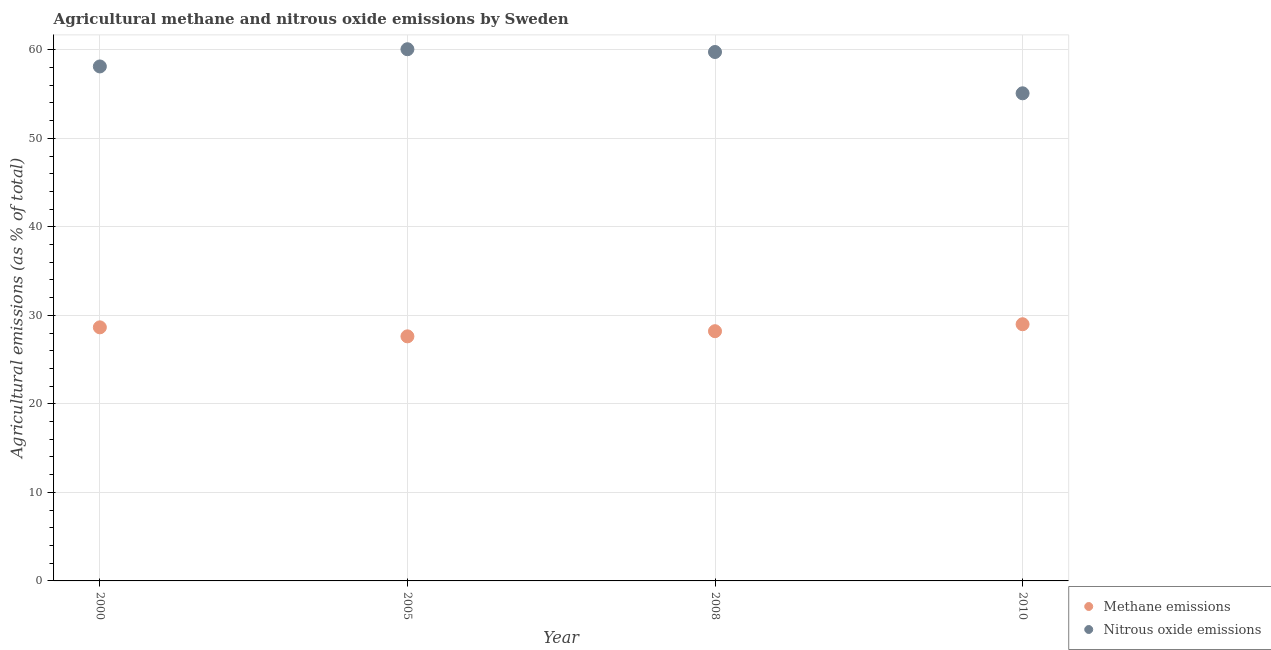What is the amount of methane emissions in 2008?
Keep it short and to the point. 28.21. Across all years, what is the maximum amount of methane emissions?
Give a very brief answer. 29. Across all years, what is the minimum amount of methane emissions?
Keep it short and to the point. 27.63. In which year was the amount of methane emissions maximum?
Keep it short and to the point. 2010. In which year was the amount of methane emissions minimum?
Your answer should be very brief. 2005. What is the total amount of methane emissions in the graph?
Provide a short and direct response. 113.48. What is the difference between the amount of nitrous oxide emissions in 2005 and that in 2008?
Offer a terse response. 0.31. What is the difference between the amount of nitrous oxide emissions in 2008 and the amount of methane emissions in 2005?
Your response must be concise. 32.12. What is the average amount of methane emissions per year?
Provide a short and direct response. 28.37. In the year 2008, what is the difference between the amount of nitrous oxide emissions and amount of methane emissions?
Your response must be concise. 31.54. What is the ratio of the amount of methane emissions in 2005 to that in 2010?
Ensure brevity in your answer.  0.95. Is the difference between the amount of nitrous oxide emissions in 2000 and 2010 greater than the difference between the amount of methane emissions in 2000 and 2010?
Ensure brevity in your answer.  Yes. What is the difference between the highest and the second highest amount of nitrous oxide emissions?
Your answer should be compact. 0.31. What is the difference between the highest and the lowest amount of methane emissions?
Your response must be concise. 1.37. Does the amount of methane emissions monotonically increase over the years?
Your answer should be very brief. No. Is the amount of methane emissions strictly less than the amount of nitrous oxide emissions over the years?
Your response must be concise. Yes. How many dotlines are there?
Ensure brevity in your answer.  2. What is the difference between two consecutive major ticks on the Y-axis?
Offer a terse response. 10. Are the values on the major ticks of Y-axis written in scientific E-notation?
Your answer should be very brief. No. Does the graph contain grids?
Provide a short and direct response. Yes. Where does the legend appear in the graph?
Keep it short and to the point. Bottom right. How are the legend labels stacked?
Your answer should be compact. Vertical. What is the title of the graph?
Provide a short and direct response. Agricultural methane and nitrous oxide emissions by Sweden. What is the label or title of the Y-axis?
Your answer should be very brief. Agricultural emissions (as % of total). What is the Agricultural emissions (as % of total) of Methane emissions in 2000?
Your answer should be very brief. 28.65. What is the Agricultural emissions (as % of total) in Nitrous oxide emissions in 2000?
Keep it short and to the point. 58.12. What is the Agricultural emissions (as % of total) in Methane emissions in 2005?
Provide a succinct answer. 27.63. What is the Agricultural emissions (as % of total) of Nitrous oxide emissions in 2005?
Your answer should be very brief. 60.06. What is the Agricultural emissions (as % of total) of Methane emissions in 2008?
Ensure brevity in your answer.  28.21. What is the Agricultural emissions (as % of total) of Nitrous oxide emissions in 2008?
Your response must be concise. 59.75. What is the Agricultural emissions (as % of total) in Methane emissions in 2010?
Offer a very short reply. 29. What is the Agricultural emissions (as % of total) in Nitrous oxide emissions in 2010?
Offer a terse response. 55.09. Across all years, what is the maximum Agricultural emissions (as % of total) in Methane emissions?
Offer a very short reply. 29. Across all years, what is the maximum Agricultural emissions (as % of total) in Nitrous oxide emissions?
Provide a succinct answer. 60.06. Across all years, what is the minimum Agricultural emissions (as % of total) in Methane emissions?
Provide a short and direct response. 27.63. Across all years, what is the minimum Agricultural emissions (as % of total) of Nitrous oxide emissions?
Offer a terse response. 55.09. What is the total Agricultural emissions (as % of total) of Methane emissions in the graph?
Offer a terse response. 113.48. What is the total Agricultural emissions (as % of total) of Nitrous oxide emissions in the graph?
Offer a very short reply. 233.02. What is the difference between the Agricultural emissions (as % of total) of Methane emissions in 2000 and that in 2005?
Offer a very short reply. 1.02. What is the difference between the Agricultural emissions (as % of total) of Nitrous oxide emissions in 2000 and that in 2005?
Keep it short and to the point. -1.94. What is the difference between the Agricultural emissions (as % of total) in Methane emissions in 2000 and that in 2008?
Your answer should be very brief. 0.44. What is the difference between the Agricultural emissions (as % of total) of Nitrous oxide emissions in 2000 and that in 2008?
Your response must be concise. -1.63. What is the difference between the Agricultural emissions (as % of total) in Methane emissions in 2000 and that in 2010?
Your answer should be compact. -0.35. What is the difference between the Agricultural emissions (as % of total) in Nitrous oxide emissions in 2000 and that in 2010?
Ensure brevity in your answer.  3.03. What is the difference between the Agricultural emissions (as % of total) of Methane emissions in 2005 and that in 2008?
Provide a succinct answer. -0.58. What is the difference between the Agricultural emissions (as % of total) in Nitrous oxide emissions in 2005 and that in 2008?
Give a very brief answer. 0.31. What is the difference between the Agricultural emissions (as % of total) in Methane emissions in 2005 and that in 2010?
Provide a succinct answer. -1.37. What is the difference between the Agricultural emissions (as % of total) in Nitrous oxide emissions in 2005 and that in 2010?
Provide a short and direct response. 4.98. What is the difference between the Agricultural emissions (as % of total) of Methane emissions in 2008 and that in 2010?
Your answer should be compact. -0.79. What is the difference between the Agricultural emissions (as % of total) of Nitrous oxide emissions in 2008 and that in 2010?
Your answer should be very brief. 4.67. What is the difference between the Agricultural emissions (as % of total) of Methane emissions in 2000 and the Agricultural emissions (as % of total) of Nitrous oxide emissions in 2005?
Your answer should be compact. -31.42. What is the difference between the Agricultural emissions (as % of total) of Methane emissions in 2000 and the Agricultural emissions (as % of total) of Nitrous oxide emissions in 2008?
Make the answer very short. -31.1. What is the difference between the Agricultural emissions (as % of total) in Methane emissions in 2000 and the Agricultural emissions (as % of total) in Nitrous oxide emissions in 2010?
Make the answer very short. -26.44. What is the difference between the Agricultural emissions (as % of total) of Methane emissions in 2005 and the Agricultural emissions (as % of total) of Nitrous oxide emissions in 2008?
Your answer should be compact. -32.12. What is the difference between the Agricultural emissions (as % of total) of Methane emissions in 2005 and the Agricultural emissions (as % of total) of Nitrous oxide emissions in 2010?
Offer a very short reply. -27.46. What is the difference between the Agricultural emissions (as % of total) in Methane emissions in 2008 and the Agricultural emissions (as % of total) in Nitrous oxide emissions in 2010?
Your response must be concise. -26.87. What is the average Agricultural emissions (as % of total) in Methane emissions per year?
Offer a terse response. 28.37. What is the average Agricultural emissions (as % of total) of Nitrous oxide emissions per year?
Your answer should be very brief. 58.26. In the year 2000, what is the difference between the Agricultural emissions (as % of total) in Methane emissions and Agricultural emissions (as % of total) in Nitrous oxide emissions?
Make the answer very short. -29.47. In the year 2005, what is the difference between the Agricultural emissions (as % of total) of Methane emissions and Agricultural emissions (as % of total) of Nitrous oxide emissions?
Your answer should be very brief. -32.44. In the year 2008, what is the difference between the Agricultural emissions (as % of total) in Methane emissions and Agricultural emissions (as % of total) in Nitrous oxide emissions?
Give a very brief answer. -31.54. In the year 2010, what is the difference between the Agricultural emissions (as % of total) of Methane emissions and Agricultural emissions (as % of total) of Nitrous oxide emissions?
Provide a short and direct response. -26.09. What is the ratio of the Agricultural emissions (as % of total) in Methane emissions in 2000 to that in 2005?
Give a very brief answer. 1.04. What is the ratio of the Agricultural emissions (as % of total) of Nitrous oxide emissions in 2000 to that in 2005?
Keep it short and to the point. 0.97. What is the ratio of the Agricultural emissions (as % of total) in Methane emissions in 2000 to that in 2008?
Ensure brevity in your answer.  1.02. What is the ratio of the Agricultural emissions (as % of total) in Nitrous oxide emissions in 2000 to that in 2008?
Make the answer very short. 0.97. What is the ratio of the Agricultural emissions (as % of total) in Methane emissions in 2000 to that in 2010?
Offer a very short reply. 0.99. What is the ratio of the Agricultural emissions (as % of total) in Nitrous oxide emissions in 2000 to that in 2010?
Your answer should be very brief. 1.06. What is the ratio of the Agricultural emissions (as % of total) of Methane emissions in 2005 to that in 2008?
Give a very brief answer. 0.98. What is the ratio of the Agricultural emissions (as % of total) in Methane emissions in 2005 to that in 2010?
Offer a terse response. 0.95. What is the ratio of the Agricultural emissions (as % of total) of Nitrous oxide emissions in 2005 to that in 2010?
Offer a terse response. 1.09. What is the ratio of the Agricultural emissions (as % of total) in Methane emissions in 2008 to that in 2010?
Keep it short and to the point. 0.97. What is the ratio of the Agricultural emissions (as % of total) of Nitrous oxide emissions in 2008 to that in 2010?
Your answer should be very brief. 1.08. What is the difference between the highest and the second highest Agricultural emissions (as % of total) in Methane emissions?
Provide a short and direct response. 0.35. What is the difference between the highest and the second highest Agricultural emissions (as % of total) of Nitrous oxide emissions?
Give a very brief answer. 0.31. What is the difference between the highest and the lowest Agricultural emissions (as % of total) of Methane emissions?
Your answer should be compact. 1.37. What is the difference between the highest and the lowest Agricultural emissions (as % of total) in Nitrous oxide emissions?
Ensure brevity in your answer.  4.98. 